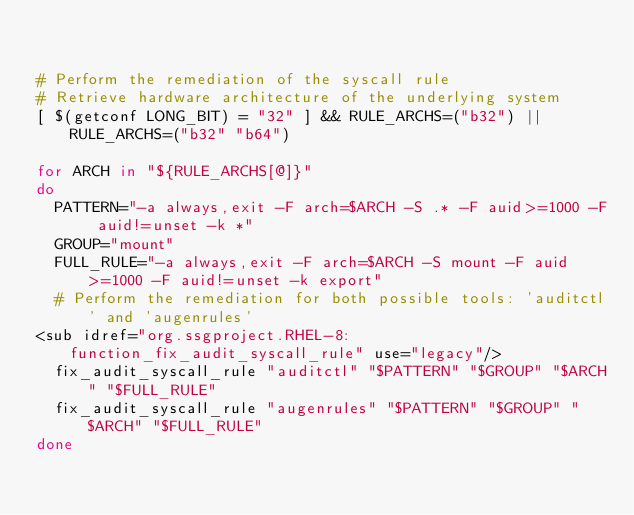<code> <loc_0><loc_0><loc_500><loc_500><_Bash_>

# Perform the remediation of the syscall rule
# Retrieve hardware architecture of the underlying system
[ $(getconf LONG_BIT) = "32" ] && RULE_ARCHS=("b32") || RULE_ARCHS=("b32" "b64")

for ARCH in "${RULE_ARCHS[@]}"
do
	PATTERN="-a always,exit -F arch=$ARCH -S .* -F auid>=1000 -F auid!=unset -k *"
	GROUP="mount"
	FULL_RULE="-a always,exit -F arch=$ARCH -S mount -F auid>=1000 -F auid!=unset -k export"
	# Perform the remediation for both possible tools: 'auditctl' and 'augenrules'
<sub idref="org.ssgproject.RHEL-8:function_fix_audit_syscall_rule" use="legacy"/>
	fix_audit_syscall_rule "auditctl" "$PATTERN" "$GROUP" "$ARCH" "$FULL_RULE"
	fix_audit_syscall_rule "augenrules" "$PATTERN" "$GROUP" "$ARCH" "$FULL_RULE"
done

              
</code> 